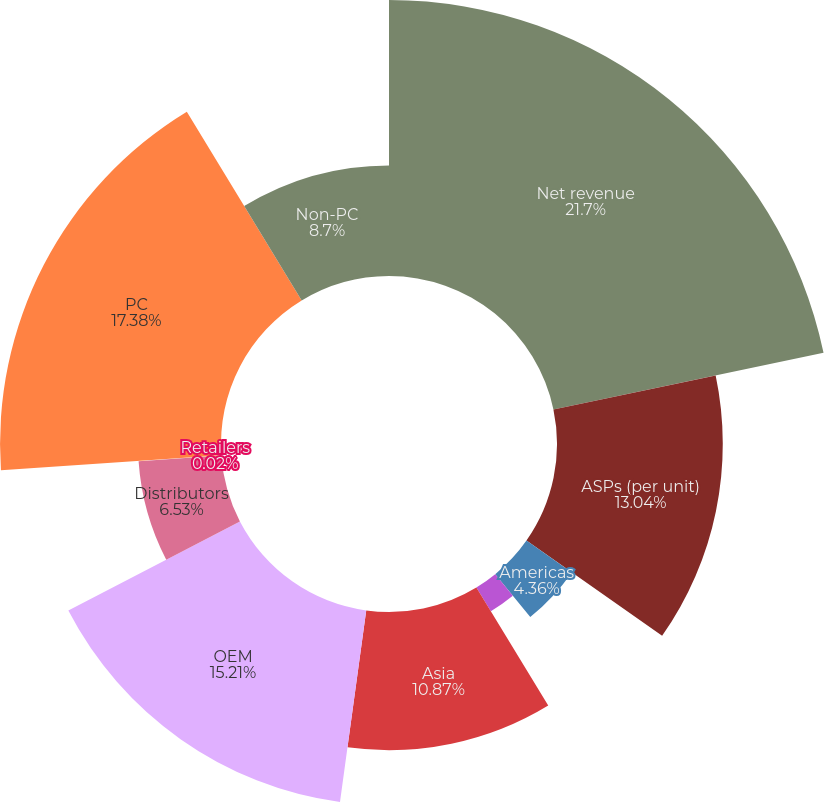Convert chart. <chart><loc_0><loc_0><loc_500><loc_500><pie_chart><fcel>Net revenue<fcel>ASPs (per unit)<fcel>Americas<fcel>Europe Middle East and Africa<fcel>Asia<fcel>OEM<fcel>Distributors<fcel>Retailers<fcel>PC<fcel>Non-PC<nl><fcel>21.71%<fcel>13.04%<fcel>4.36%<fcel>2.19%<fcel>10.87%<fcel>15.21%<fcel>6.53%<fcel>0.02%<fcel>17.38%<fcel>8.7%<nl></chart> 